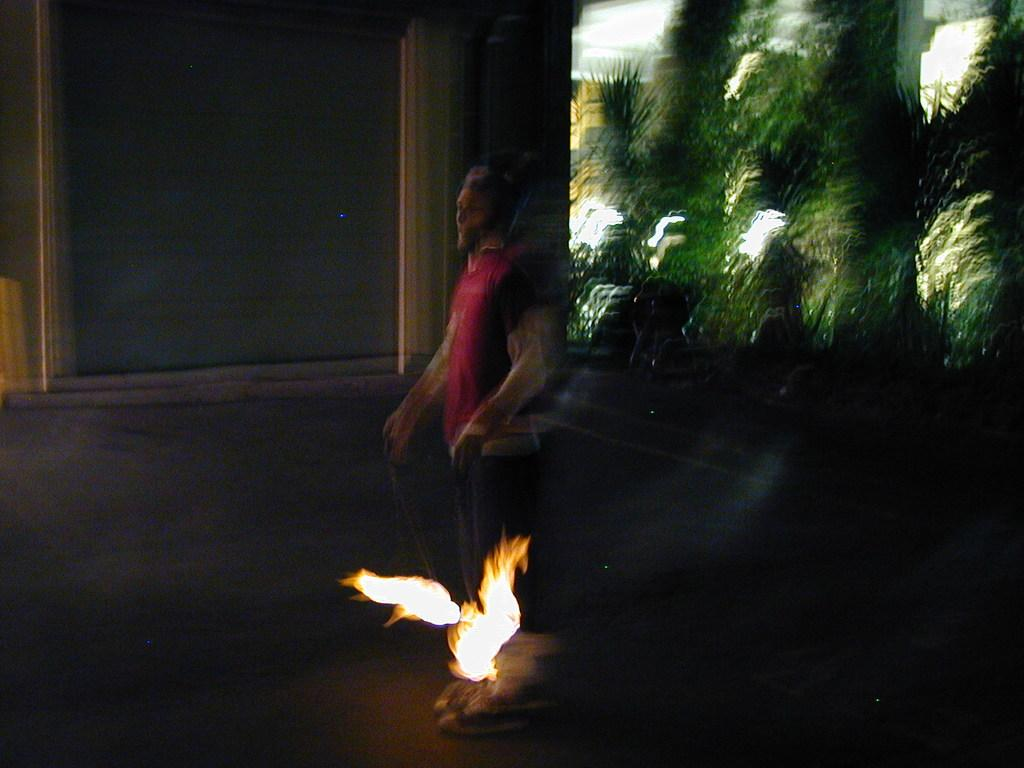What is happening in the foreground of the image? There is a person walking in the foreground of the image. What is the person holding in the image? The person is holding fireballs. What can be seen on the right side of the image? There are trees and lights on the right side of the image. What is located on the left side of the image? There is a wall on the left side of the image. How many geese are flying in the scene depicted in the image? There are no geese present in the image. Are the two brothers in the image holding hands while walking? There is no mention of brothers or holding hands in the image. 